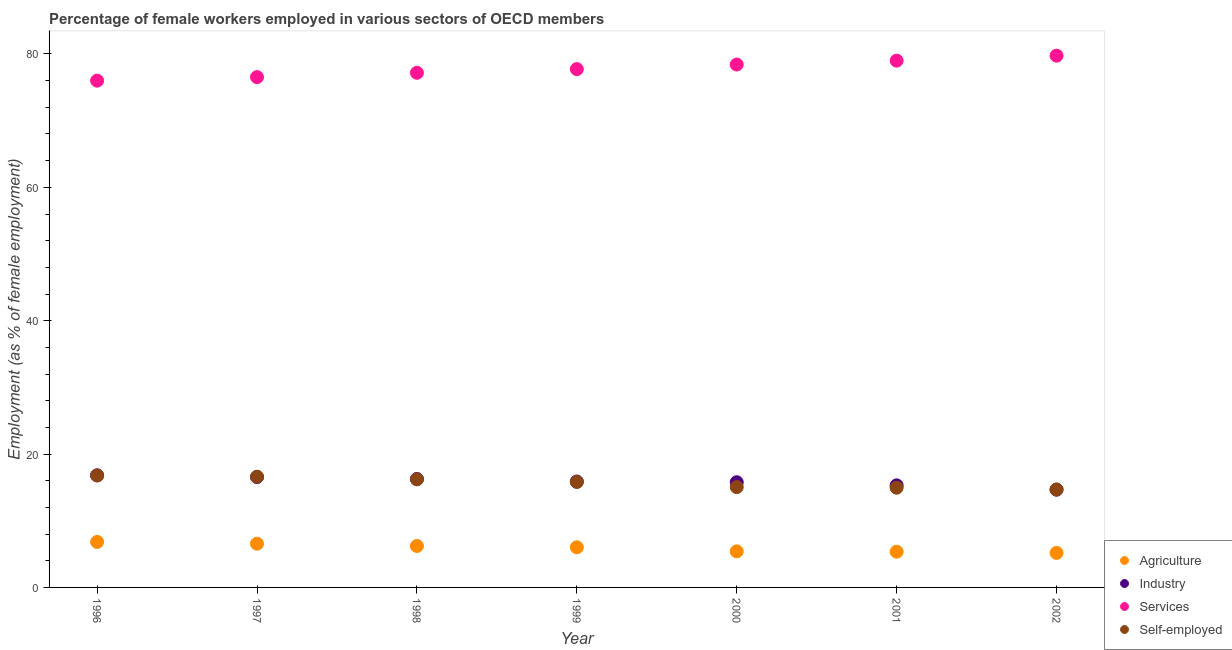How many different coloured dotlines are there?
Give a very brief answer. 4. What is the percentage of female workers in services in 1997?
Ensure brevity in your answer.  76.53. Across all years, what is the maximum percentage of self employed female workers?
Your answer should be very brief. 16.8. Across all years, what is the minimum percentage of female workers in agriculture?
Offer a very short reply. 5.18. In which year was the percentage of female workers in services maximum?
Give a very brief answer. 2002. In which year was the percentage of self employed female workers minimum?
Offer a very short reply. 2002. What is the total percentage of female workers in agriculture in the graph?
Your answer should be compact. 41.55. What is the difference between the percentage of female workers in agriculture in 1998 and that in 1999?
Give a very brief answer. 0.2. What is the difference between the percentage of female workers in agriculture in 2001 and the percentage of self employed female workers in 2000?
Ensure brevity in your answer.  -9.69. What is the average percentage of female workers in agriculture per year?
Your response must be concise. 5.94. In the year 2002, what is the difference between the percentage of female workers in services and percentage of female workers in agriculture?
Your answer should be very brief. 74.57. In how many years, is the percentage of female workers in services greater than 32 %?
Ensure brevity in your answer.  7. What is the ratio of the percentage of female workers in services in 1999 to that in 2000?
Your answer should be very brief. 0.99. What is the difference between the highest and the second highest percentage of female workers in industry?
Your response must be concise. 0.25. What is the difference between the highest and the lowest percentage of female workers in services?
Offer a terse response. 3.74. In how many years, is the percentage of self employed female workers greater than the average percentage of self employed female workers taken over all years?
Your response must be concise. 4. Is the percentage of female workers in agriculture strictly greater than the percentage of self employed female workers over the years?
Offer a very short reply. No. How many years are there in the graph?
Offer a terse response. 7. What is the difference between two consecutive major ticks on the Y-axis?
Make the answer very short. 20. Are the values on the major ticks of Y-axis written in scientific E-notation?
Ensure brevity in your answer.  No. Where does the legend appear in the graph?
Your answer should be very brief. Bottom right. What is the title of the graph?
Provide a short and direct response. Percentage of female workers employed in various sectors of OECD members. What is the label or title of the Y-axis?
Give a very brief answer. Employment (as % of female employment). What is the Employment (as % of female employment) of Agriculture in 1996?
Your answer should be compact. 6.82. What is the Employment (as % of female employment) in Industry in 1996?
Offer a terse response. 16.8. What is the Employment (as % of female employment) in Services in 1996?
Offer a very short reply. 76. What is the Employment (as % of female employment) of Self-employed in 1996?
Keep it short and to the point. 16.8. What is the Employment (as % of female employment) of Agriculture in 1997?
Give a very brief answer. 6.56. What is the Employment (as % of female employment) of Industry in 1997?
Provide a succinct answer. 16.55. What is the Employment (as % of female employment) in Services in 1997?
Keep it short and to the point. 76.53. What is the Employment (as % of female employment) of Self-employed in 1997?
Your response must be concise. 16.6. What is the Employment (as % of female employment) in Agriculture in 1998?
Your response must be concise. 6.22. What is the Employment (as % of female employment) in Industry in 1998?
Your response must be concise. 16.26. What is the Employment (as % of female employment) of Services in 1998?
Ensure brevity in your answer.  77.18. What is the Employment (as % of female employment) in Self-employed in 1998?
Offer a very short reply. 16.21. What is the Employment (as % of female employment) of Agriculture in 1999?
Provide a succinct answer. 6.02. What is the Employment (as % of female employment) of Industry in 1999?
Provide a succinct answer. 15.89. What is the Employment (as % of female employment) in Services in 1999?
Ensure brevity in your answer.  77.73. What is the Employment (as % of female employment) of Self-employed in 1999?
Your answer should be compact. 15.82. What is the Employment (as % of female employment) in Agriculture in 2000?
Your answer should be very brief. 5.4. What is the Employment (as % of female employment) in Industry in 2000?
Provide a short and direct response. 15.78. What is the Employment (as % of female employment) of Services in 2000?
Provide a succinct answer. 78.42. What is the Employment (as % of female employment) of Self-employed in 2000?
Your response must be concise. 15.05. What is the Employment (as % of female employment) of Agriculture in 2001?
Make the answer very short. 5.35. What is the Employment (as % of female employment) in Industry in 2001?
Keep it short and to the point. 15.31. What is the Employment (as % of female employment) of Services in 2001?
Offer a very short reply. 79. What is the Employment (as % of female employment) of Self-employed in 2001?
Your answer should be compact. 14.95. What is the Employment (as % of female employment) of Agriculture in 2002?
Provide a short and direct response. 5.18. What is the Employment (as % of female employment) of Industry in 2002?
Offer a very short reply. 14.66. What is the Employment (as % of female employment) in Services in 2002?
Offer a very short reply. 79.74. What is the Employment (as % of female employment) in Self-employed in 2002?
Offer a terse response. 14.69. Across all years, what is the maximum Employment (as % of female employment) in Agriculture?
Give a very brief answer. 6.82. Across all years, what is the maximum Employment (as % of female employment) in Industry?
Ensure brevity in your answer.  16.8. Across all years, what is the maximum Employment (as % of female employment) of Services?
Provide a succinct answer. 79.74. Across all years, what is the maximum Employment (as % of female employment) in Self-employed?
Give a very brief answer. 16.8. Across all years, what is the minimum Employment (as % of female employment) in Agriculture?
Make the answer very short. 5.18. Across all years, what is the minimum Employment (as % of female employment) in Industry?
Your response must be concise. 14.66. Across all years, what is the minimum Employment (as % of female employment) of Services?
Offer a terse response. 76. Across all years, what is the minimum Employment (as % of female employment) in Self-employed?
Provide a succinct answer. 14.69. What is the total Employment (as % of female employment) of Agriculture in the graph?
Your response must be concise. 41.55. What is the total Employment (as % of female employment) in Industry in the graph?
Provide a succinct answer. 111.25. What is the total Employment (as % of female employment) of Services in the graph?
Ensure brevity in your answer.  544.6. What is the total Employment (as % of female employment) in Self-employed in the graph?
Ensure brevity in your answer.  110.11. What is the difference between the Employment (as % of female employment) of Agriculture in 1996 and that in 1997?
Provide a short and direct response. 0.26. What is the difference between the Employment (as % of female employment) of Industry in 1996 and that in 1997?
Your answer should be compact. 0.25. What is the difference between the Employment (as % of female employment) in Services in 1996 and that in 1997?
Provide a succinct answer. -0.53. What is the difference between the Employment (as % of female employment) of Self-employed in 1996 and that in 1997?
Make the answer very short. 0.2. What is the difference between the Employment (as % of female employment) in Agriculture in 1996 and that in 1998?
Make the answer very short. 0.6. What is the difference between the Employment (as % of female employment) in Industry in 1996 and that in 1998?
Ensure brevity in your answer.  0.54. What is the difference between the Employment (as % of female employment) in Services in 1996 and that in 1998?
Make the answer very short. -1.18. What is the difference between the Employment (as % of female employment) in Self-employed in 1996 and that in 1998?
Ensure brevity in your answer.  0.59. What is the difference between the Employment (as % of female employment) in Agriculture in 1996 and that in 1999?
Ensure brevity in your answer.  0.8. What is the difference between the Employment (as % of female employment) in Industry in 1996 and that in 1999?
Offer a terse response. 0.92. What is the difference between the Employment (as % of female employment) of Services in 1996 and that in 1999?
Offer a terse response. -1.73. What is the difference between the Employment (as % of female employment) of Self-employed in 1996 and that in 1999?
Provide a short and direct response. 0.98. What is the difference between the Employment (as % of female employment) of Agriculture in 1996 and that in 2000?
Provide a short and direct response. 1.41. What is the difference between the Employment (as % of female employment) of Industry in 1996 and that in 2000?
Keep it short and to the point. 1.03. What is the difference between the Employment (as % of female employment) of Services in 1996 and that in 2000?
Give a very brief answer. -2.42. What is the difference between the Employment (as % of female employment) of Self-employed in 1996 and that in 2000?
Offer a terse response. 1.75. What is the difference between the Employment (as % of female employment) in Agriculture in 1996 and that in 2001?
Offer a terse response. 1.47. What is the difference between the Employment (as % of female employment) in Industry in 1996 and that in 2001?
Your answer should be compact. 1.5. What is the difference between the Employment (as % of female employment) in Services in 1996 and that in 2001?
Provide a short and direct response. -3. What is the difference between the Employment (as % of female employment) of Self-employed in 1996 and that in 2001?
Make the answer very short. 1.84. What is the difference between the Employment (as % of female employment) of Agriculture in 1996 and that in 2002?
Your answer should be compact. 1.64. What is the difference between the Employment (as % of female employment) in Industry in 1996 and that in 2002?
Offer a terse response. 2.15. What is the difference between the Employment (as % of female employment) of Services in 1996 and that in 2002?
Give a very brief answer. -3.74. What is the difference between the Employment (as % of female employment) in Self-employed in 1996 and that in 2002?
Make the answer very short. 2.11. What is the difference between the Employment (as % of female employment) of Agriculture in 1997 and that in 1998?
Give a very brief answer. 0.34. What is the difference between the Employment (as % of female employment) in Industry in 1997 and that in 1998?
Your response must be concise. 0.29. What is the difference between the Employment (as % of female employment) in Services in 1997 and that in 1998?
Your answer should be compact. -0.65. What is the difference between the Employment (as % of female employment) of Self-employed in 1997 and that in 1998?
Your response must be concise. 0.39. What is the difference between the Employment (as % of female employment) of Agriculture in 1997 and that in 1999?
Give a very brief answer. 0.54. What is the difference between the Employment (as % of female employment) of Industry in 1997 and that in 1999?
Offer a very short reply. 0.67. What is the difference between the Employment (as % of female employment) in Services in 1997 and that in 1999?
Make the answer very short. -1.2. What is the difference between the Employment (as % of female employment) in Self-employed in 1997 and that in 1999?
Provide a succinct answer. 0.79. What is the difference between the Employment (as % of female employment) of Agriculture in 1997 and that in 2000?
Your answer should be very brief. 1.15. What is the difference between the Employment (as % of female employment) in Industry in 1997 and that in 2000?
Your answer should be very brief. 0.77. What is the difference between the Employment (as % of female employment) of Services in 1997 and that in 2000?
Keep it short and to the point. -1.89. What is the difference between the Employment (as % of female employment) of Self-employed in 1997 and that in 2000?
Your response must be concise. 1.55. What is the difference between the Employment (as % of female employment) of Agriculture in 1997 and that in 2001?
Offer a very short reply. 1.2. What is the difference between the Employment (as % of female employment) of Industry in 1997 and that in 2001?
Your response must be concise. 1.24. What is the difference between the Employment (as % of female employment) of Services in 1997 and that in 2001?
Make the answer very short. -2.47. What is the difference between the Employment (as % of female employment) in Self-employed in 1997 and that in 2001?
Make the answer very short. 1.65. What is the difference between the Employment (as % of female employment) in Agriculture in 1997 and that in 2002?
Offer a terse response. 1.38. What is the difference between the Employment (as % of female employment) in Industry in 1997 and that in 2002?
Offer a terse response. 1.89. What is the difference between the Employment (as % of female employment) in Services in 1997 and that in 2002?
Your response must be concise. -3.22. What is the difference between the Employment (as % of female employment) in Self-employed in 1997 and that in 2002?
Ensure brevity in your answer.  1.91. What is the difference between the Employment (as % of female employment) of Agriculture in 1998 and that in 1999?
Offer a terse response. 0.2. What is the difference between the Employment (as % of female employment) in Industry in 1998 and that in 1999?
Offer a very short reply. 0.37. What is the difference between the Employment (as % of female employment) in Services in 1998 and that in 1999?
Your answer should be compact. -0.55. What is the difference between the Employment (as % of female employment) of Self-employed in 1998 and that in 1999?
Provide a succinct answer. 0.4. What is the difference between the Employment (as % of female employment) in Agriculture in 1998 and that in 2000?
Your answer should be compact. 0.81. What is the difference between the Employment (as % of female employment) of Industry in 1998 and that in 2000?
Offer a terse response. 0.48. What is the difference between the Employment (as % of female employment) in Services in 1998 and that in 2000?
Your answer should be compact. -1.24. What is the difference between the Employment (as % of female employment) in Self-employed in 1998 and that in 2000?
Provide a short and direct response. 1.17. What is the difference between the Employment (as % of female employment) in Agriculture in 1998 and that in 2001?
Provide a succinct answer. 0.86. What is the difference between the Employment (as % of female employment) in Industry in 1998 and that in 2001?
Make the answer very short. 0.95. What is the difference between the Employment (as % of female employment) of Services in 1998 and that in 2001?
Provide a succinct answer. -1.82. What is the difference between the Employment (as % of female employment) in Self-employed in 1998 and that in 2001?
Keep it short and to the point. 1.26. What is the difference between the Employment (as % of female employment) in Agriculture in 1998 and that in 2002?
Give a very brief answer. 1.04. What is the difference between the Employment (as % of female employment) in Industry in 1998 and that in 2002?
Provide a short and direct response. 1.6. What is the difference between the Employment (as % of female employment) of Services in 1998 and that in 2002?
Ensure brevity in your answer.  -2.57. What is the difference between the Employment (as % of female employment) in Self-employed in 1998 and that in 2002?
Your response must be concise. 1.52. What is the difference between the Employment (as % of female employment) of Agriculture in 1999 and that in 2000?
Offer a terse response. 0.61. What is the difference between the Employment (as % of female employment) in Industry in 1999 and that in 2000?
Provide a succinct answer. 0.11. What is the difference between the Employment (as % of female employment) of Services in 1999 and that in 2000?
Ensure brevity in your answer.  -0.69. What is the difference between the Employment (as % of female employment) in Self-employed in 1999 and that in 2000?
Provide a succinct answer. 0.77. What is the difference between the Employment (as % of female employment) in Agriculture in 1999 and that in 2001?
Provide a succinct answer. 0.66. What is the difference between the Employment (as % of female employment) in Industry in 1999 and that in 2001?
Keep it short and to the point. 0.58. What is the difference between the Employment (as % of female employment) of Services in 1999 and that in 2001?
Provide a succinct answer. -1.27. What is the difference between the Employment (as % of female employment) of Self-employed in 1999 and that in 2001?
Offer a very short reply. 0.86. What is the difference between the Employment (as % of female employment) in Agriculture in 1999 and that in 2002?
Make the answer very short. 0.84. What is the difference between the Employment (as % of female employment) in Industry in 1999 and that in 2002?
Provide a succinct answer. 1.23. What is the difference between the Employment (as % of female employment) of Services in 1999 and that in 2002?
Your answer should be compact. -2.01. What is the difference between the Employment (as % of female employment) of Self-employed in 1999 and that in 2002?
Your response must be concise. 1.13. What is the difference between the Employment (as % of female employment) in Agriculture in 2000 and that in 2001?
Give a very brief answer. 0.05. What is the difference between the Employment (as % of female employment) of Industry in 2000 and that in 2001?
Your response must be concise. 0.47. What is the difference between the Employment (as % of female employment) in Services in 2000 and that in 2001?
Your answer should be compact. -0.58. What is the difference between the Employment (as % of female employment) of Self-employed in 2000 and that in 2001?
Provide a short and direct response. 0.09. What is the difference between the Employment (as % of female employment) in Agriculture in 2000 and that in 2002?
Keep it short and to the point. 0.23. What is the difference between the Employment (as % of female employment) of Industry in 2000 and that in 2002?
Your answer should be compact. 1.12. What is the difference between the Employment (as % of female employment) of Services in 2000 and that in 2002?
Provide a succinct answer. -1.33. What is the difference between the Employment (as % of female employment) in Self-employed in 2000 and that in 2002?
Provide a succinct answer. 0.36. What is the difference between the Employment (as % of female employment) in Agriculture in 2001 and that in 2002?
Your answer should be very brief. 0.18. What is the difference between the Employment (as % of female employment) in Industry in 2001 and that in 2002?
Ensure brevity in your answer.  0.65. What is the difference between the Employment (as % of female employment) of Services in 2001 and that in 2002?
Give a very brief answer. -0.74. What is the difference between the Employment (as % of female employment) in Self-employed in 2001 and that in 2002?
Ensure brevity in your answer.  0.27. What is the difference between the Employment (as % of female employment) in Agriculture in 1996 and the Employment (as % of female employment) in Industry in 1997?
Provide a succinct answer. -9.73. What is the difference between the Employment (as % of female employment) in Agriculture in 1996 and the Employment (as % of female employment) in Services in 1997?
Offer a terse response. -69.71. What is the difference between the Employment (as % of female employment) of Agriculture in 1996 and the Employment (as % of female employment) of Self-employed in 1997?
Ensure brevity in your answer.  -9.78. What is the difference between the Employment (as % of female employment) of Industry in 1996 and the Employment (as % of female employment) of Services in 1997?
Offer a very short reply. -59.72. What is the difference between the Employment (as % of female employment) in Industry in 1996 and the Employment (as % of female employment) in Self-employed in 1997?
Your response must be concise. 0.2. What is the difference between the Employment (as % of female employment) of Services in 1996 and the Employment (as % of female employment) of Self-employed in 1997?
Your answer should be very brief. 59.4. What is the difference between the Employment (as % of female employment) of Agriculture in 1996 and the Employment (as % of female employment) of Industry in 1998?
Ensure brevity in your answer.  -9.44. What is the difference between the Employment (as % of female employment) of Agriculture in 1996 and the Employment (as % of female employment) of Services in 1998?
Give a very brief answer. -70.36. What is the difference between the Employment (as % of female employment) of Agriculture in 1996 and the Employment (as % of female employment) of Self-employed in 1998?
Give a very brief answer. -9.39. What is the difference between the Employment (as % of female employment) of Industry in 1996 and the Employment (as % of female employment) of Services in 1998?
Your answer should be very brief. -60.37. What is the difference between the Employment (as % of female employment) in Industry in 1996 and the Employment (as % of female employment) in Self-employed in 1998?
Make the answer very short. 0.59. What is the difference between the Employment (as % of female employment) in Services in 1996 and the Employment (as % of female employment) in Self-employed in 1998?
Your answer should be very brief. 59.79. What is the difference between the Employment (as % of female employment) in Agriculture in 1996 and the Employment (as % of female employment) in Industry in 1999?
Give a very brief answer. -9.07. What is the difference between the Employment (as % of female employment) in Agriculture in 1996 and the Employment (as % of female employment) in Services in 1999?
Give a very brief answer. -70.91. What is the difference between the Employment (as % of female employment) of Agriculture in 1996 and the Employment (as % of female employment) of Self-employed in 1999?
Offer a very short reply. -9. What is the difference between the Employment (as % of female employment) of Industry in 1996 and the Employment (as % of female employment) of Services in 1999?
Your answer should be compact. -60.93. What is the difference between the Employment (as % of female employment) of Services in 1996 and the Employment (as % of female employment) of Self-employed in 1999?
Your answer should be very brief. 60.19. What is the difference between the Employment (as % of female employment) in Agriculture in 1996 and the Employment (as % of female employment) in Industry in 2000?
Provide a short and direct response. -8.96. What is the difference between the Employment (as % of female employment) in Agriculture in 1996 and the Employment (as % of female employment) in Services in 2000?
Give a very brief answer. -71.6. What is the difference between the Employment (as % of female employment) in Agriculture in 1996 and the Employment (as % of female employment) in Self-employed in 2000?
Keep it short and to the point. -8.23. What is the difference between the Employment (as % of female employment) of Industry in 1996 and the Employment (as % of female employment) of Services in 2000?
Make the answer very short. -61.61. What is the difference between the Employment (as % of female employment) in Industry in 1996 and the Employment (as % of female employment) in Self-employed in 2000?
Offer a very short reply. 1.76. What is the difference between the Employment (as % of female employment) in Services in 1996 and the Employment (as % of female employment) in Self-employed in 2000?
Give a very brief answer. 60.95. What is the difference between the Employment (as % of female employment) in Agriculture in 1996 and the Employment (as % of female employment) in Industry in 2001?
Provide a short and direct response. -8.49. What is the difference between the Employment (as % of female employment) of Agriculture in 1996 and the Employment (as % of female employment) of Services in 2001?
Your answer should be compact. -72.18. What is the difference between the Employment (as % of female employment) of Agriculture in 1996 and the Employment (as % of female employment) of Self-employed in 2001?
Your answer should be very brief. -8.14. What is the difference between the Employment (as % of female employment) in Industry in 1996 and the Employment (as % of female employment) in Services in 2001?
Make the answer very short. -62.2. What is the difference between the Employment (as % of female employment) of Industry in 1996 and the Employment (as % of female employment) of Self-employed in 2001?
Make the answer very short. 1.85. What is the difference between the Employment (as % of female employment) of Services in 1996 and the Employment (as % of female employment) of Self-employed in 2001?
Give a very brief answer. 61.05. What is the difference between the Employment (as % of female employment) of Agriculture in 1996 and the Employment (as % of female employment) of Industry in 2002?
Offer a terse response. -7.84. What is the difference between the Employment (as % of female employment) of Agriculture in 1996 and the Employment (as % of female employment) of Services in 2002?
Your answer should be compact. -72.92. What is the difference between the Employment (as % of female employment) in Agriculture in 1996 and the Employment (as % of female employment) in Self-employed in 2002?
Ensure brevity in your answer.  -7.87. What is the difference between the Employment (as % of female employment) in Industry in 1996 and the Employment (as % of female employment) in Services in 2002?
Ensure brevity in your answer.  -62.94. What is the difference between the Employment (as % of female employment) of Industry in 1996 and the Employment (as % of female employment) of Self-employed in 2002?
Keep it short and to the point. 2.12. What is the difference between the Employment (as % of female employment) in Services in 1996 and the Employment (as % of female employment) in Self-employed in 2002?
Offer a very short reply. 61.31. What is the difference between the Employment (as % of female employment) in Agriculture in 1997 and the Employment (as % of female employment) in Industry in 1998?
Make the answer very short. -9.7. What is the difference between the Employment (as % of female employment) in Agriculture in 1997 and the Employment (as % of female employment) in Services in 1998?
Your response must be concise. -70.62. What is the difference between the Employment (as % of female employment) in Agriculture in 1997 and the Employment (as % of female employment) in Self-employed in 1998?
Offer a very short reply. -9.65. What is the difference between the Employment (as % of female employment) of Industry in 1997 and the Employment (as % of female employment) of Services in 1998?
Keep it short and to the point. -60.63. What is the difference between the Employment (as % of female employment) in Industry in 1997 and the Employment (as % of female employment) in Self-employed in 1998?
Your answer should be very brief. 0.34. What is the difference between the Employment (as % of female employment) of Services in 1997 and the Employment (as % of female employment) of Self-employed in 1998?
Provide a succinct answer. 60.32. What is the difference between the Employment (as % of female employment) of Agriculture in 1997 and the Employment (as % of female employment) of Industry in 1999?
Provide a short and direct response. -9.33. What is the difference between the Employment (as % of female employment) in Agriculture in 1997 and the Employment (as % of female employment) in Services in 1999?
Provide a short and direct response. -71.17. What is the difference between the Employment (as % of female employment) of Agriculture in 1997 and the Employment (as % of female employment) of Self-employed in 1999?
Your answer should be compact. -9.26. What is the difference between the Employment (as % of female employment) of Industry in 1997 and the Employment (as % of female employment) of Services in 1999?
Provide a short and direct response. -61.18. What is the difference between the Employment (as % of female employment) of Industry in 1997 and the Employment (as % of female employment) of Self-employed in 1999?
Provide a short and direct response. 0.74. What is the difference between the Employment (as % of female employment) in Services in 1997 and the Employment (as % of female employment) in Self-employed in 1999?
Your answer should be very brief. 60.71. What is the difference between the Employment (as % of female employment) of Agriculture in 1997 and the Employment (as % of female employment) of Industry in 2000?
Ensure brevity in your answer.  -9.22. What is the difference between the Employment (as % of female employment) of Agriculture in 1997 and the Employment (as % of female employment) of Services in 2000?
Ensure brevity in your answer.  -71.86. What is the difference between the Employment (as % of female employment) of Agriculture in 1997 and the Employment (as % of female employment) of Self-employed in 2000?
Your answer should be very brief. -8.49. What is the difference between the Employment (as % of female employment) in Industry in 1997 and the Employment (as % of female employment) in Services in 2000?
Offer a terse response. -61.87. What is the difference between the Employment (as % of female employment) of Industry in 1997 and the Employment (as % of female employment) of Self-employed in 2000?
Provide a succinct answer. 1.51. What is the difference between the Employment (as % of female employment) in Services in 1997 and the Employment (as % of female employment) in Self-employed in 2000?
Keep it short and to the point. 61.48. What is the difference between the Employment (as % of female employment) in Agriculture in 1997 and the Employment (as % of female employment) in Industry in 2001?
Ensure brevity in your answer.  -8.75. What is the difference between the Employment (as % of female employment) in Agriculture in 1997 and the Employment (as % of female employment) in Services in 2001?
Your response must be concise. -72.44. What is the difference between the Employment (as % of female employment) of Agriculture in 1997 and the Employment (as % of female employment) of Self-employed in 2001?
Your response must be concise. -8.4. What is the difference between the Employment (as % of female employment) in Industry in 1997 and the Employment (as % of female employment) in Services in 2001?
Provide a succinct answer. -62.45. What is the difference between the Employment (as % of female employment) of Industry in 1997 and the Employment (as % of female employment) of Self-employed in 2001?
Keep it short and to the point. 1.6. What is the difference between the Employment (as % of female employment) in Services in 1997 and the Employment (as % of female employment) in Self-employed in 2001?
Provide a succinct answer. 61.57. What is the difference between the Employment (as % of female employment) in Agriculture in 1997 and the Employment (as % of female employment) in Industry in 2002?
Your response must be concise. -8.1. What is the difference between the Employment (as % of female employment) in Agriculture in 1997 and the Employment (as % of female employment) in Services in 2002?
Keep it short and to the point. -73.19. What is the difference between the Employment (as % of female employment) of Agriculture in 1997 and the Employment (as % of female employment) of Self-employed in 2002?
Offer a terse response. -8.13. What is the difference between the Employment (as % of female employment) in Industry in 1997 and the Employment (as % of female employment) in Services in 2002?
Make the answer very short. -63.19. What is the difference between the Employment (as % of female employment) of Industry in 1997 and the Employment (as % of female employment) of Self-employed in 2002?
Your answer should be very brief. 1.86. What is the difference between the Employment (as % of female employment) of Services in 1997 and the Employment (as % of female employment) of Self-employed in 2002?
Your response must be concise. 61.84. What is the difference between the Employment (as % of female employment) in Agriculture in 1998 and the Employment (as % of female employment) in Industry in 1999?
Provide a short and direct response. -9.67. What is the difference between the Employment (as % of female employment) of Agriculture in 1998 and the Employment (as % of female employment) of Services in 1999?
Make the answer very short. -71.51. What is the difference between the Employment (as % of female employment) of Agriculture in 1998 and the Employment (as % of female employment) of Self-employed in 1999?
Ensure brevity in your answer.  -9.6. What is the difference between the Employment (as % of female employment) in Industry in 1998 and the Employment (as % of female employment) in Services in 1999?
Keep it short and to the point. -61.47. What is the difference between the Employment (as % of female employment) of Industry in 1998 and the Employment (as % of female employment) of Self-employed in 1999?
Ensure brevity in your answer.  0.45. What is the difference between the Employment (as % of female employment) in Services in 1998 and the Employment (as % of female employment) in Self-employed in 1999?
Provide a short and direct response. 61.36. What is the difference between the Employment (as % of female employment) in Agriculture in 1998 and the Employment (as % of female employment) in Industry in 2000?
Provide a short and direct response. -9.56. What is the difference between the Employment (as % of female employment) of Agriculture in 1998 and the Employment (as % of female employment) of Services in 2000?
Keep it short and to the point. -72.2. What is the difference between the Employment (as % of female employment) of Agriculture in 1998 and the Employment (as % of female employment) of Self-employed in 2000?
Keep it short and to the point. -8.83. What is the difference between the Employment (as % of female employment) in Industry in 1998 and the Employment (as % of female employment) in Services in 2000?
Offer a terse response. -62.16. What is the difference between the Employment (as % of female employment) in Industry in 1998 and the Employment (as % of female employment) in Self-employed in 2000?
Provide a succinct answer. 1.22. What is the difference between the Employment (as % of female employment) in Services in 1998 and the Employment (as % of female employment) in Self-employed in 2000?
Your answer should be compact. 62.13. What is the difference between the Employment (as % of female employment) of Agriculture in 1998 and the Employment (as % of female employment) of Industry in 2001?
Give a very brief answer. -9.09. What is the difference between the Employment (as % of female employment) of Agriculture in 1998 and the Employment (as % of female employment) of Services in 2001?
Make the answer very short. -72.78. What is the difference between the Employment (as % of female employment) in Agriculture in 1998 and the Employment (as % of female employment) in Self-employed in 2001?
Give a very brief answer. -8.74. What is the difference between the Employment (as % of female employment) of Industry in 1998 and the Employment (as % of female employment) of Services in 2001?
Make the answer very short. -62.74. What is the difference between the Employment (as % of female employment) in Industry in 1998 and the Employment (as % of female employment) in Self-employed in 2001?
Make the answer very short. 1.31. What is the difference between the Employment (as % of female employment) in Services in 1998 and the Employment (as % of female employment) in Self-employed in 2001?
Your answer should be very brief. 62.22. What is the difference between the Employment (as % of female employment) in Agriculture in 1998 and the Employment (as % of female employment) in Industry in 2002?
Provide a short and direct response. -8.44. What is the difference between the Employment (as % of female employment) in Agriculture in 1998 and the Employment (as % of female employment) in Services in 2002?
Your answer should be compact. -73.53. What is the difference between the Employment (as % of female employment) of Agriculture in 1998 and the Employment (as % of female employment) of Self-employed in 2002?
Give a very brief answer. -8.47. What is the difference between the Employment (as % of female employment) of Industry in 1998 and the Employment (as % of female employment) of Services in 2002?
Your answer should be compact. -63.48. What is the difference between the Employment (as % of female employment) of Industry in 1998 and the Employment (as % of female employment) of Self-employed in 2002?
Provide a succinct answer. 1.57. What is the difference between the Employment (as % of female employment) of Services in 1998 and the Employment (as % of female employment) of Self-employed in 2002?
Give a very brief answer. 62.49. What is the difference between the Employment (as % of female employment) of Agriculture in 1999 and the Employment (as % of female employment) of Industry in 2000?
Your answer should be compact. -9.76. What is the difference between the Employment (as % of female employment) in Agriculture in 1999 and the Employment (as % of female employment) in Services in 2000?
Offer a very short reply. -72.4. What is the difference between the Employment (as % of female employment) of Agriculture in 1999 and the Employment (as % of female employment) of Self-employed in 2000?
Offer a very short reply. -9.03. What is the difference between the Employment (as % of female employment) in Industry in 1999 and the Employment (as % of female employment) in Services in 2000?
Provide a short and direct response. -62.53. What is the difference between the Employment (as % of female employment) in Industry in 1999 and the Employment (as % of female employment) in Self-employed in 2000?
Provide a succinct answer. 0.84. What is the difference between the Employment (as % of female employment) in Services in 1999 and the Employment (as % of female employment) in Self-employed in 2000?
Provide a succinct answer. 62.69. What is the difference between the Employment (as % of female employment) in Agriculture in 1999 and the Employment (as % of female employment) in Industry in 2001?
Your answer should be compact. -9.29. What is the difference between the Employment (as % of female employment) in Agriculture in 1999 and the Employment (as % of female employment) in Services in 2001?
Keep it short and to the point. -72.98. What is the difference between the Employment (as % of female employment) of Agriculture in 1999 and the Employment (as % of female employment) of Self-employed in 2001?
Give a very brief answer. -8.94. What is the difference between the Employment (as % of female employment) of Industry in 1999 and the Employment (as % of female employment) of Services in 2001?
Keep it short and to the point. -63.11. What is the difference between the Employment (as % of female employment) in Industry in 1999 and the Employment (as % of female employment) in Self-employed in 2001?
Provide a short and direct response. 0.93. What is the difference between the Employment (as % of female employment) of Services in 1999 and the Employment (as % of female employment) of Self-employed in 2001?
Your response must be concise. 62.78. What is the difference between the Employment (as % of female employment) in Agriculture in 1999 and the Employment (as % of female employment) in Industry in 2002?
Ensure brevity in your answer.  -8.64. What is the difference between the Employment (as % of female employment) of Agriculture in 1999 and the Employment (as % of female employment) of Services in 2002?
Provide a succinct answer. -73.73. What is the difference between the Employment (as % of female employment) of Agriculture in 1999 and the Employment (as % of female employment) of Self-employed in 2002?
Provide a succinct answer. -8.67. What is the difference between the Employment (as % of female employment) in Industry in 1999 and the Employment (as % of female employment) in Services in 2002?
Make the answer very short. -63.86. What is the difference between the Employment (as % of female employment) in Industry in 1999 and the Employment (as % of female employment) in Self-employed in 2002?
Offer a terse response. 1.2. What is the difference between the Employment (as % of female employment) in Services in 1999 and the Employment (as % of female employment) in Self-employed in 2002?
Keep it short and to the point. 63.04. What is the difference between the Employment (as % of female employment) in Agriculture in 2000 and the Employment (as % of female employment) in Industry in 2001?
Ensure brevity in your answer.  -9.9. What is the difference between the Employment (as % of female employment) in Agriculture in 2000 and the Employment (as % of female employment) in Services in 2001?
Ensure brevity in your answer.  -73.59. What is the difference between the Employment (as % of female employment) of Agriculture in 2000 and the Employment (as % of female employment) of Self-employed in 2001?
Offer a terse response. -9.55. What is the difference between the Employment (as % of female employment) in Industry in 2000 and the Employment (as % of female employment) in Services in 2001?
Your response must be concise. -63.22. What is the difference between the Employment (as % of female employment) in Industry in 2000 and the Employment (as % of female employment) in Self-employed in 2001?
Offer a terse response. 0.82. What is the difference between the Employment (as % of female employment) of Services in 2000 and the Employment (as % of female employment) of Self-employed in 2001?
Ensure brevity in your answer.  63.46. What is the difference between the Employment (as % of female employment) in Agriculture in 2000 and the Employment (as % of female employment) in Industry in 2002?
Your response must be concise. -9.25. What is the difference between the Employment (as % of female employment) in Agriculture in 2000 and the Employment (as % of female employment) in Services in 2002?
Offer a very short reply. -74.34. What is the difference between the Employment (as % of female employment) of Agriculture in 2000 and the Employment (as % of female employment) of Self-employed in 2002?
Offer a very short reply. -9.28. What is the difference between the Employment (as % of female employment) of Industry in 2000 and the Employment (as % of female employment) of Services in 2002?
Provide a succinct answer. -63.97. What is the difference between the Employment (as % of female employment) in Industry in 2000 and the Employment (as % of female employment) in Self-employed in 2002?
Provide a succinct answer. 1.09. What is the difference between the Employment (as % of female employment) of Services in 2000 and the Employment (as % of female employment) of Self-employed in 2002?
Give a very brief answer. 63.73. What is the difference between the Employment (as % of female employment) in Agriculture in 2001 and the Employment (as % of female employment) in Industry in 2002?
Provide a succinct answer. -9.3. What is the difference between the Employment (as % of female employment) in Agriculture in 2001 and the Employment (as % of female employment) in Services in 2002?
Your answer should be compact. -74.39. What is the difference between the Employment (as % of female employment) of Agriculture in 2001 and the Employment (as % of female employment) of Self-employed in 2002?
Your response must be concise. -9.33. What is the difference between the Employment (as % of female employment) of Industry in 2001 and the Employment (as % of female employment) of Services in 2002?
Offer a terse response. -64.44. What is the difference between the Employment (as % of female employment) in Industry in 2001 and the Employment (as % of female employment) in Self-employed in 2002?
Make the answer very short. 0.62. What is the difference between the Employment (as % of female employment) of Services in 2001 and the Employment (as % of female employment) of Self-employed in 2002?
Provide a succinct answer. 64.31. What is the average Employment (as % of female employment) in Agriculture per year?
Make the answer very short. 5.94. What is the average Employment (as % of female employment) in Industry per year?
Provide a succinct answer. 15.89. What is the average Employment (as % of female employment) of Services per year?
Ensure brevity in your answer.  77.8. What is the average Employment (as % of female employment) in Self-employed per year?
Provide a short and direct response. 15.73. In the year 1996, what is the difference between the Employment (as % of female employment) of Agriculture and Employment (as % of female employment) of Industry?
Offer a very short reply. -9.99. In the year 1996, what is the difference between the Employment (as % of female employment) in Agriculture and Employment (as % of female employment) in Services?
Your response must be concise. -69.18. In the year 1996, what is the difference between the Employment (as % of female employment) in Agriculture and Employment (as % of female employment) in Self-employed?
Your response must be concise. -9.98. In the year 1996, what is the difference between the Employment (as % of female employment) of Industry and Employment (as % of female employment) of Services?
Provide a succinct answer. -59.2. In the year 1996, what is the difference between the Employment (as % of female employment) in Industry and Employment (as % of female employment) in Self-employed?
Give a very brief answer. 0.01. In the year 1996, what is the difference between the Employment (as % of female employment) of Services and Employment (as % of female employment) of Self-employed?
Your answer should be very brief. 59.2. In the year 1997, what is the difference between the Employment (as % of female employment) in Agriculture and Employment (as % of female employment) in Industry?
Ensure brevity in your answer.  -9.99. In the year 1997, what is the difference between the Employment (as % of female employment) of Agriculture and Employment (as % of female employment) of Services?
Your answer should be very brief. -69.97. In the year 1997, what is the difference between the Employment (as % of female employment) in Agriculture and Employment (as % of female employment) in Self-employed?
Make the answer very short. -10.04. In the year 1997, what is the difference between the Employment (as % of female employment) in Industry and Employment (as % of female employment) in Services?
Make the answer very short. -59.97. In the year 1997, what is the difference between the Employment (as % of female employment) in Industry and Employment (as % of female employment) in Self-employed?
Offer a terse response. -0.05. In the year 1997, what is the difference between the Employment (as % of female employment) in Services and Employment (as % of female employment) in Self-employed?
Provide a short and direct response. 59.93. In the year 1998, what is the difference between the Employment (as % of female employment) in Agriculture and Employment (as % of female employment) in Industry?
Offer a very short reply. -10.04. In the year 1998, what is the difference between the Employment (as % of female employment) of Agriculture and Employment (as % of female employment) of Services?
Ensure brevity in your answer.  -70.96. In the year 1998, what is the difference between the Employment (as % of female employment) in Agriculture and Employment (as % of female employment) in Self-employed?
Ensure brevity in your answer.  -9.99. In the year 1998, what is the difference between the Employment (as % of female employment) in Industry and Employment (as % of female employment) in Services?
Provide a short and direct response. -60.92. In the year 1998, what is the difference between the Employment (as % of female employment) of Industry and Employment (as % of female employment) of Self-employed?
Provide a succinct answer. 0.05. In the year 1998, what is the difference between the Employment (as % of female employment) in Services and Employment (as % of female employment) in Self-employed?
Provide a short and direct response. 60.97. In the year 1999, what is the difference between the Employment (as % of female employment) of Agriculture and Employment (as % of female employment) of Industry?
Your answer should be compact. -9.87. In the year 1999, what is the difference between the Employment (as % of female employment) of Agriculture and Employment (as % of female employment) of Services?
Provide a succinct answer. -71.71. In the year 1999, what is the difference between the Employment (as % of female employment) of Agriculture and Employment (as % of female employment) of Self-employed?
Make the answer very short. -9.8. In the year 1999, what is the difference between the Employment (as % of female employment) in Industry and Employment (as % of female employment) in Services?
Provide a short and direct response. -61.84. In the year 1999, what is the difference between the Employment (as % of female employment) of Industry and Employment (as % of female employment) of Self-employed?
Offer a very short reply. 0.07. In the year 1999, what is the difference between the Employment (as % of female employment) of Services and Employment (as % of female employment) of Self-employed?
Your answer should be compact. 61.92. In the year 2000, what is the difference between the Employment (as % of female employment) in Agriculture and Employment (as % of female employment) in Industry?
Your answer should be compact. -10.37. In the year 2000, what is the difference between the Employment (as % of female employment) in Agriculture and Employment (as % of female employment) in Services?
Ensure brevity in your answer.  -73.01. In the year 2000, what is the difference between the Employment (as % of female employment) in Agriculture and Employment (as % of female employment) in Self-employed?
Provide a succinct answer. -9.64. In the year 2000, what is the difference between the Employment (as % of female employment) in Industry and Employment (as % of female employment) in Services?
Make the answer very short. -62.64. In the year 2000, what is the difference between the Employment (as % of female employment) of Industry and Employment (as % of female employment) of Self-employed?
Make the answer very short. 0.73. In the year 2000, what is the difference between the Employment (as % of female employment) of Services and Employment (as % of female employment) of Self-employed?
Make the answer very short. 63.37. In the year 2001, what is the difference between the Employment (as % of female employment) in Agriculture and Employment (as % of female employment) in Industry?
Offer a very short reply. -9.95. In the year 2001, what is the difference between the Employment (as % of female employment) in Agriculture and Employment (as % of female employment) in Services?
Give a very brief answer. -73.65. In the year 2001, what is the difference between the Employment (as % of female employment) in Agriculture and Employment (as % of female employment) in Self-employed?
Provide a short and direct response. -9.6. In the year 2001, what is the difference between the Employment (as % of female employment) in Industry and Employment (as % of female employment) in Services?
Make the answer very short. -63.69. In the year 2001, what is the difference between the Employment (as % of female employment) in Industry and Employment (as % of female employment) in Self-employed?
Provide a short and direct response. 0.35. In the year 2001, what is the difference between the Employment (as % of female employment) of Services and Employment (as % of female employment) of Self-employed?
Provide a succinct answer. 64.05. In the year 2002, what is the difference between the Employment (as % of female employment) in Agriculture and Employment (as % of female employment) in Industry?
Your answer should be compact. -9.48. In the year 2002, what is the difference between the Employment (as % of female employment) in Agriculture and Employment (as % of female employment) in Services?
Ensure brevity in your answer.  -74.57. In the year 2002, what is the difference between the Employment (as % of female employment) of Agriculture and Employment (as % of female employment) of Self-employed?
Provide a short and direct response. -9.51. In the year 2002, what is the difference between the Employment (as % of female employment) of Industry and Employment (as % of female employment) of Services?
Keep it short and to the point. -65.09. In the year 2002, what is the difference between the Employment (as % of female employment) of Industry and Employment (as % of female employment) of Self-employed?
Provide a succinct answer. -0.03. In the year 2002, what is the difference between the Employment (as % of female employment) of Services and Employment (as % of female employment) of Self-employed?
Make the answer very short. 65.06. What is the ratio of the Employment (as % of female employment) in Agriculture in 1996 to that in 1997?
Your answer should be very brief. 1.04. What is the ratio of the Employment (as % of female employment) in Industry in 1996 to that in 1997?
Keep it short and to the point. 1.02. What is the ratio of the Employment (as % of female employment) of Services in 1996 to that in 1997?
Offer a very short reply. 0.99. What is the ratio of the Employment (as % of female employment) of Self-employed in 1996 to that in 1997?
Give a very brief answer. 1.01. What is the ratio of the Employment (as % of female employment) in Agriculture in 1996 to that in 1998?
Your answer should be very brief. 1.1. What is the ratio of the Employment (as % of female employment) in Industry in 1996 to that in 1998?
Provide a short and direct response. 1.03. What is the ratio of the Employment (as % of female employment) in Services in 1996 to that in 1998?
Keep it short and to the point. 0.98. What is the ratio of the Employment (as % of female employment) in Self-employed in 1996 to that in 1998?
Ensure brevity in your answer.  1.04. What is the ratio of the Employment (as % of female employment) of Agriculture in 1996 to that in 1999?
Give a very brief answer. 1.13. What is the ratio of the Employment (as % of female employment) in Industry in 1996 to that in 1999?
Ensure brevity in your answer.  1.06. What is the ratio of the Employment (as % of female employment) in Services in 1996 to that in 1999?
Ensure brevity in your answer.  0.98. What is the ratio of the Employment (as % of female employment) in Self-employed in 1996 to that in 1999?
Keep it short and to the point. 1.06. What is the ratio of the Employment (as % of female employment) in Agriculture in 1996 to that in 2000?
Provide a short and direct response. 1.26. What is the ratio of the Employment (as % of female employment) in Industry in 1996 to that in 2000?
Ensure brevity in your answer.  1.06. What is the ratio of the Employment (as % of female employment) of Services in 1996 to that in 2000?
Provide a short and direct response. 0.97. What is the ratio of the Employment (as % of female employment) of Self-employed in 1996 to that in 2000?
Provide a short and direct response. 1.12. What is the ratio of the Employment (as % of female employment) in Agriculture in 1996 to that in 2001?
Your answer should be very brief. 1.27. What is the ratio of the Employment (as % of female employment) in Industry in 1996 to that in 2001?
Ensure brevity in your answer.  1.1. What is the ratio of the Employment (as % of female employment) of Services in 1996 to that in 2001?
Offer a very short reply. 0.96. What is the ratio of the Employment (as % of female employment) of Self-employed in 1996 to that in 2001?
Your answer should be very brief. 1.12. What is the ratio of the Employment (as % of female employment) of Agriculture in 1996 to that in 2002?
Give a very brief answer. 1.32. What is the ratio of the Employment (as % of female employment) in Industry in 1996 to that in 2002?
Make the answer very short. 1.15. What is the ratio of the Employment (as % of female employment) in Services in 1996 to that in 2002?
Offer a very short reply. 0.95. What is the ratio of the Employment (as % of female employment) of Self-employed in 1996 to that in 2002?
Provide a succinct answer. 1.14. What is the ratio of the Employment (as % of female employment) of Agriculture in 1997 to that in 1998?
Make the answer very short. 1.05. What is the ratio of the Employment (as % of female employment) in Industry in 1997 to that in 1998?
Offer a terse response. 1.02. What is the ratio of the Employment (as % of female employment) of Self-employed in 1997 to that in 1998?
Give a very brief answer. 1.02. What is the ratio of the Employment (as % of female employment) in Agriculture in 1997 to that in 1999?
Your answer should be very brief. 1.09. What is the ratio of the Employment (as % of female employment) in Industry in 1997 to that in 1999?
Ensure brevity in your answer.  1.04. What is the ratio of the Employment (as % of female employment) of Services in 1997 to that in 1999?
Your answer should be compact. 0.98. What is the ratio of the Employment (as % of female employment) in Self-employed in 1997 to that in 1999?
Provide a short and direct response. 1.05. What is the ratio of the Employment (as % of female employment) of Agriculture in 1997 to that in 2000?
Offer a terse response. 1.21. What is the ratio of the Employment (as % of female employment) of Industry in 1997 to that in 2000?
Your response must be concise. 1.05. What is the ratio of the Employment (as % of female employment) of Services in 1997 to that in 2000?
Offer a terse response. 0.98. What is the ratio of the Employment (as % of female employment) of Self-employed in 1997 to that in 2000?
Offer a very short reply. 1.1. What is the ratio of the Employment (as % of female employment) of Agriculture in 1997 to that in 2001?
Keep it short and to the point. 1.23. What is the ratio of the Employment (as % of female employment) of Industry in 1997 to that in 2001?
Provide a succinct answer. 1.08. What is the ratio of the Employment (as % of female employment) of Services in 1997 to that in 2001?
Offer a very short reply. 0.97. What is the ratio of the Employment (as % of female employment) in Self-employed in 1997 to that in 2001?
Your response must be concise. 1.11. What is the ratio of the Employment (as % of female employment) in Agriculture in 1997 to that in 2002?
Offer a very short reply. 1.27. What is the ratio of the Employment (as % of female employment) in Industry in 1997 to that in 2002?
Give a very brief answer. 1.13. What is the ratio of the Employment (as % of female employment) of Services in 1997 to that in 2002?
Provide a succinct answer. 0.96. What is the ratio of the Employment (as % of female employment) in Self-employed in 1997 to that in 2002?
Provide a short and direct response. 1.13. What is the ratio of the Employment (as % of female employment) in Agriculture in 1998 to that in 1999?
Your answer should be compact. 1.03. What is the ratio of the Employment (as % of female employment) of Industry in 1998 to that in 1999?
Your response must be concise. 1.02. What is the ratio of the Employment (as % of female employment) in Self-employed in 1998 to that in 1999?
Provide a short and direct response. 1.03. What is the ratio of the Employment (as % of female employment) in Agriculture in 1998 to that in 2000?
Offer a very short reply. 1.15. What is the ratio of the Employment (as % of female employment) in Industry in 1998 to that in 2000?
Your answer should be compact. 1.03. What is the ratio of the Employment (as % of female employment) in Services in 1998 to that in 2000?
Make the answer very short. 0.98. What is the ratio of the Employment (as % of female employment) of Self-employed in 1998 to that in 2000?
Offer a very short reply. 1.08. What is the ratio of the Employment (as % of female employment) of Agriculture in 1998 to that in 2001?
Give a very brief answer. 1.16. What is the ratio of the Employment (as % of female employment) of Industry in 1998 to that in 2001?
Your answer should be very brief. 1.06. What is the ratio of the Employment (as % of female employment) in Services in 1998 to that in 2001?
Offer a terse response. 0.98. What is the ratio of the Employment (as % of female employment) in Self-employed in 1998 to that in 2001?
Give a very brief answer. 1.08. What is the ratio of the Employment (as % of female employment) in Agriculture in 1998 to that in 2002?
Keep it short and to the point. 1.2. What is the ratio of the Employment (as % of female employment) of Industry in 1998 to that in 2002?
Offer a very short reply. 1.11. What is the ratio of the Employment (as % of female employment) in Services in 1998 to that in 2002?
Your answer should be compact. 0.97. What is the ratio of the Employment (as % of female employment) of Self-employed in 1998 to that in 2002?
Provide a succinct answer. 1.1. What is the ratio of the Employment (as % of female employment) in Agriculture in 1999 to that in 2000?
Keep it short and to the point. 1.11. What is the ratio of the Employment (as % of female employment) of Industry in 1999 to that in 2000?
Provide a short and direct response. 1.01. What is the ratio of the Employment (as % of female employment) in Self-employed in 1999 to that in 2000?
Provide a short and direct response. 1.05. What is the ratio of the Employment (as % of female employment) in Agriculture in 1999 to that in 2001?
Ensure brevity in your answer.  1.12. What is the ratio of the Employment (as % of female employment) in Industry in 1999 to that in 2001?
Make the answer very short. 1.04. What is the ratio of the Employment (as % of female employment) in Services in 1999 to that in 2001?
Offer a terse response. 0.98. What is the ratio of the Employment (as % of female employment) of Self-employed in 1999 to that in 2001?
Provide a short and direct response. 1.06. What is the ratio of the Employment (as % of female employment) in Agriculture in 1999 to that in 2002?
Your answer should be compact. 1.16. What is the ratio of the Employment (as % of female employment) in Industry in 1999 to that in 2002?
Your answer should be very brief. 1.08. What is the ratio of the Employment (as % of female employment) in Services in 1999 to that in 2002?
Provide a succinct answer. 0.97. What is the ratio of the Employment (as % of female employment) in Self-employed in 1999 to that in 2002?
Offer a terse response. 1.08. What is the ratio of the Employment (as % of female employment) of Agriculture in 2000 to that in 2001?
Your response must be concise. 1.01. What is the ratio of the Employment (as % of female employment) in Industry in 2000 to that in 2001?
Offer a terse response. 1.03. What is the ratio of the Employment (as % of female employment) of Agriculture in 2000 to that in 2002?
Provide a short and direct response. 1.04. What is the ratio of the Employment (as % of female employment) in Industry in 2000 to that in 2002?
Your answer should be very brief. 1.08. What is the ratio of the Employment (as % of female employment) in Services in 2000 to that in 2002?
Make the answer very short. 0.98. What is the ratio of the Employment (as % of female employment) in Self-employed in 2000 to that in 2002?
Your response must be concise. 1.02. What is the ratio of the Employment (as % of female employment) of Agriculture in 2001 to that in 2002?
Your answer should be compact. 1.03. What is the ratio of the Employment (as % of female employment) of Industry in 2001 to that in 2002?
Provide a succinct answer. 1.04. What is the ratio of the Employment (as % of female employment) in Services in 2001 to that in 2002?
Offer a terse response. 0.99. What is the ratio of the Employment (as % of female employment) in Self-employed in 2001 to that in 2002?
Provide a succinct answer. 1.02. What is the difference between the highest and the second highest Employment (as % of female employment) in Agriculture?
Ensure brevity in your answer.  0.26. What is the difference between the highest and the second highest Employment (as % of female employment) of Industry?
Offer a very short reply. 0.25. What is the difference between the highest and the second highest Employment (as % of female employment) in Services?
Keep it short and to the point. 0.74. What is the difference between the highest and the second highest Employment (as % of female employment) of Self-employed?
Give a very brief answer. 0.2. What is the difference between the highest and the lowest Employment (as % of female employment) of Agriculture?
Make the answer very short. 1.64. What is the difference between the highest and the lowest Employment (as % of female employment) of Industry?
Offer a terse response. 2.15. What is the difference between the highest and the lowest Employment (as % of female employment) in Services?
Your answer should be compact. 3.74. What is the difference between the highest and the lowest Employment (as % of female employment) of Self-employed?
Offer a terse response. 2.11. 